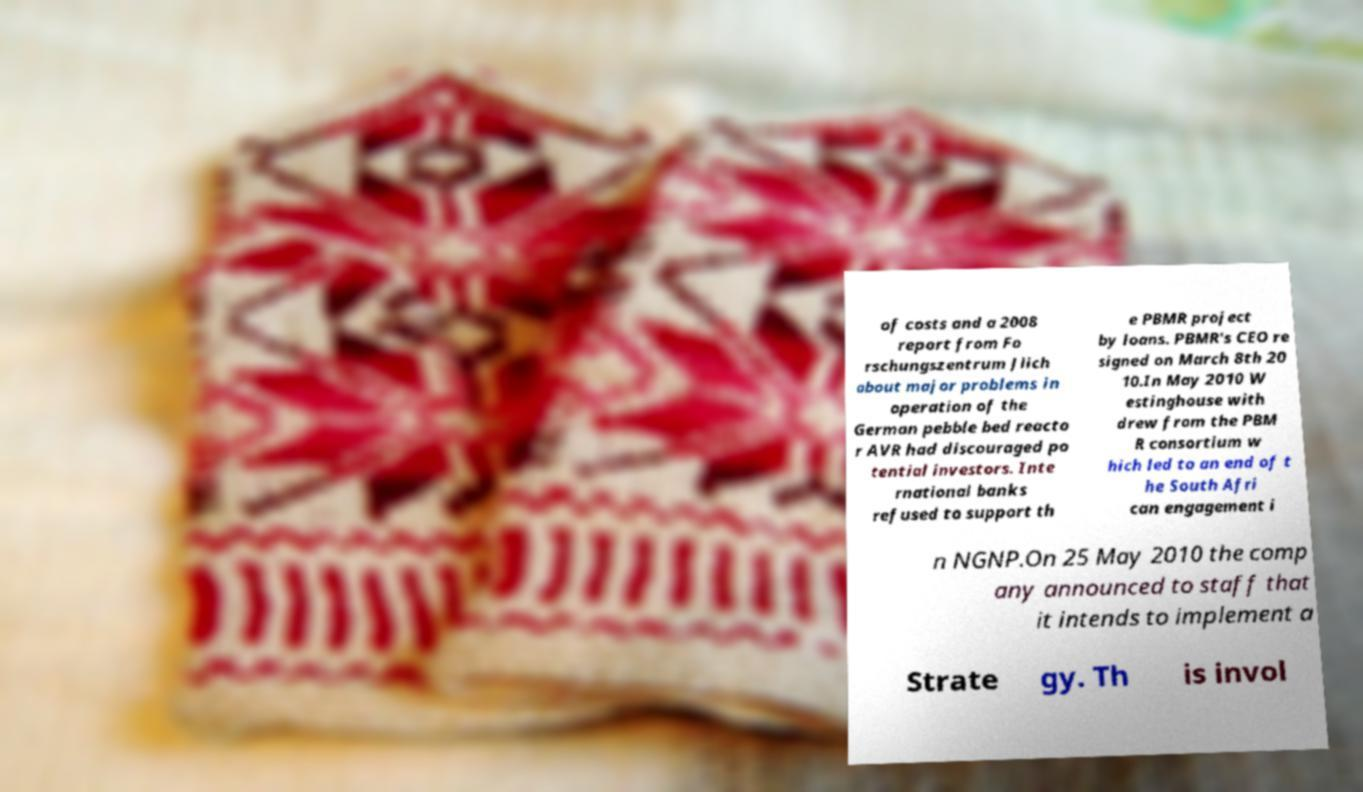Can you accurately transcribe the text from the provided image for me? of costs and a 2008 report from Fo rschungszentrum Jlich about major problems in operation of the German pebble bed reacto r AVR had discouraged po tential investors. Inte rnational banks refused to support th e PBMR project by loans. PBMR's CEO re signed on March 8th 20 10.In May 2010 W estinghouse with drew from the PBM R consortium w hich led to an end of t he South Afri can engagement i n NGNP.On 25 May 2010 the comp any announced to staff that it intends to implement a Strate gy. Th is invol 